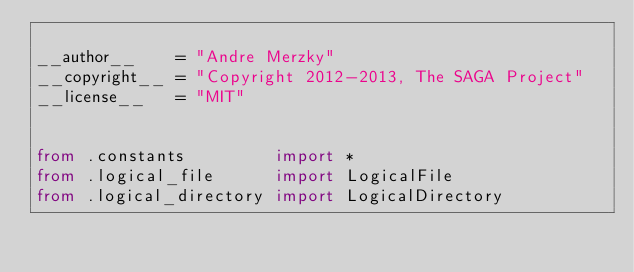<code> <loc_0><loc_0><loc_500><loc_500><_Python_>
__author__    = "Andre Merzky"
__copyright__ = "Copyright 2012-2013, The SAGA Project"
__license__   = "MIT"


from .constants         import *
from .logical_file      import LogicalFile
from .logical_directory import LogicalDirectory

</code> 